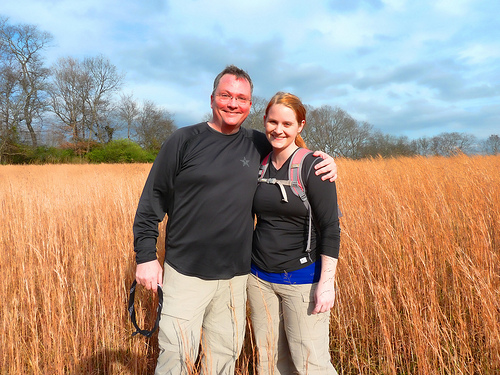<image>
Is there a girl on the boy? No. The girl is not positioned on the boy. They may be near each other, but the girl is not supported by or resting on top of the boy. Is the man on the woman? No. The man is not positioned on the woman. They may be near each other, but the man is not supported by or resting on top of the woman. Where is the grass in relation to the man? Is it under the man? Yes. The grass is positioned underneath the man, with the man above it in the vertical space. Is the woman behind the man? No. The woman is not behind the man. From this viewpoint, the woman appears to be positioned elsewhere in the scene. 